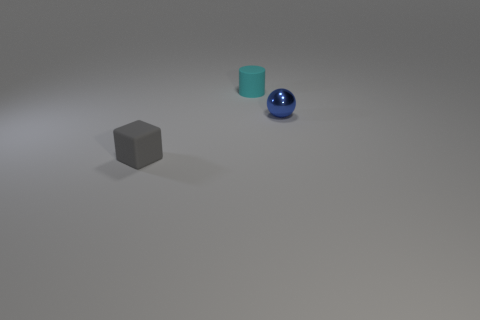Add 1 big purple metallic cylinders. How many objects exist? 4 Subtract all balls. How many objects are left? 2 Add 1 small rubber cubes. How many small rubber cubes exist? 2 Subtract 0 red cylinders. How many objects are left? 3 Subtract all small cubes. Subtract all matte cylinders. How many objects are left? 1 Add 2 small gray matte things. How many small gray matte things are left? 3 